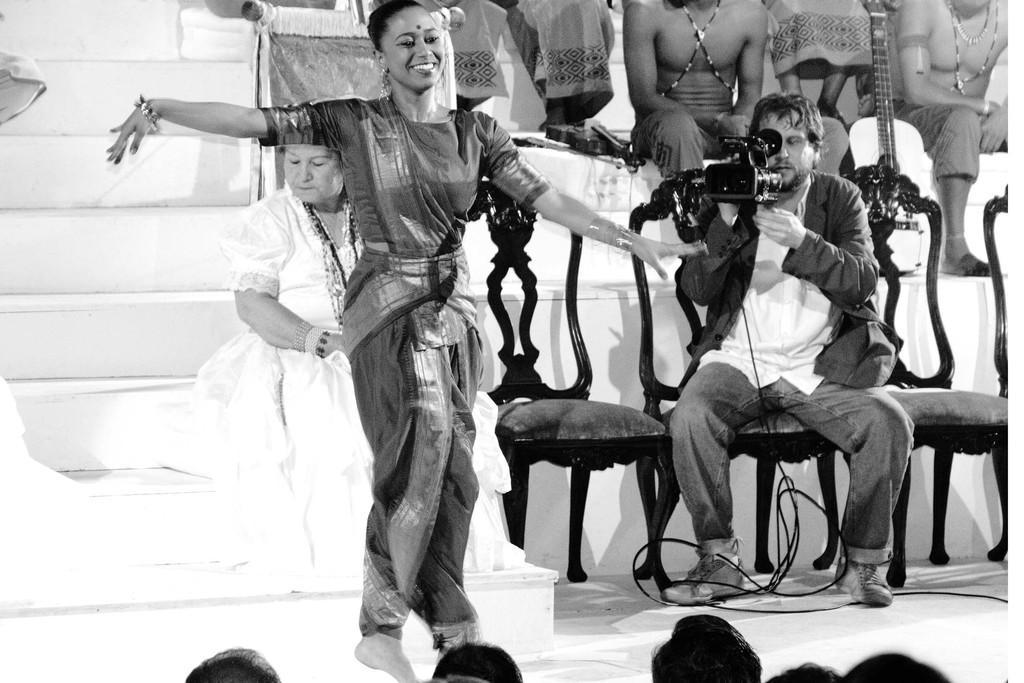How would you summarize this image in a sentence or two? In this image there is a woman dancing with a smile on her face, behind the women there are a few other person's seated, behind the woman there is a person holding a camera. 